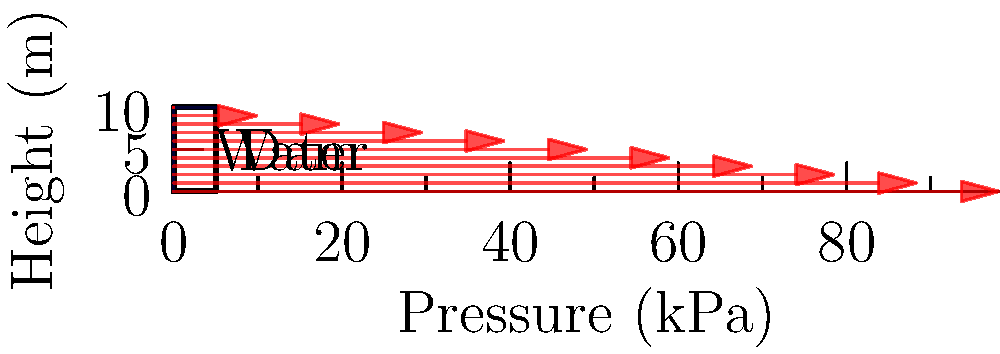Consider a rectangular dam wall of height 10 m submerged in water. Given that the density of water is 1000 kg/m³ and gravitational acceleration is 9.81 m/s², calculate the total force exerted by the water on the dam wall per unit width. Express your answer in kN/m. To solve this problem, we'll use the principles of hydrostatic pressure distribution:

1) The pressure at any depth h is given by $p = \rho g h$, where:
   $\rho$ = density of water = 1000 kg/m³
   $g$ = gravitational acceleration = 9.81 m/s²
   $h$ = depth from the water surface

2) The pressure distribution is triangular, with zero pressure at the water surface and maximum pressure at the bottom of the dam.

3) The maximum pressure at the bottom (h = 10 m) is:
   $p_{max} = 1000 \cdot 9.81 \cdot 10 = 98100$ Pa = 98.1 kPa

4) The total force is the area of this pressure distribution triangle:
   $F = \frac{1}{2} \cdot base \cdot height$
   
   Here, base = maximum pressure = 98.1 kPa
         height = dam height = 10 m

5) Therefore, $F = \frac{1}{2} \cdot 98.1 \cdot 10 = 490.5$ kN/m

This force acts at the centroid of the triangle, which is at 1/3 of the height from the bottom, but this information wasn't requested in the question.
Answer: 490.5 kN/m 